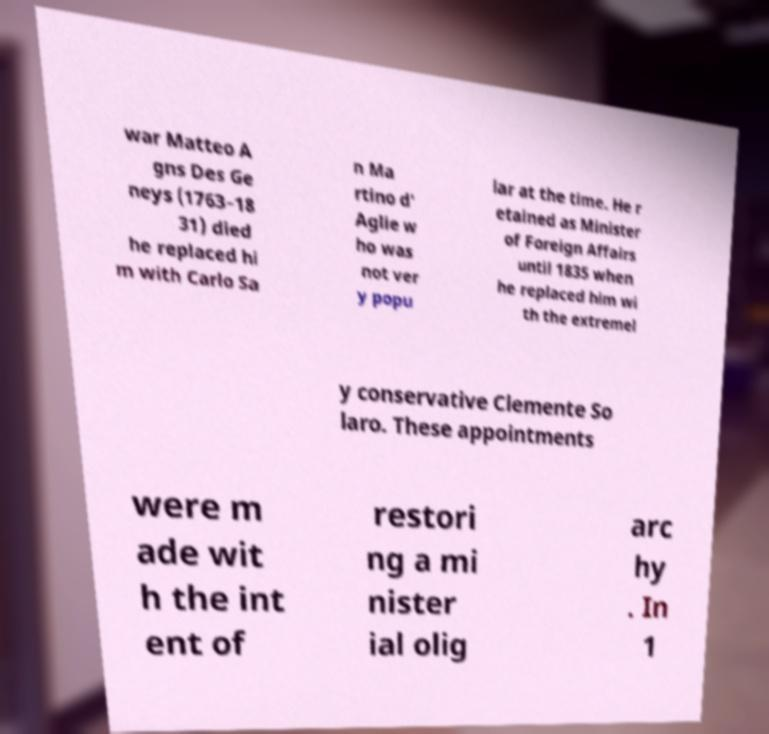Please identify and transcribe the text found in this image. war Matteo A gns Des Ge neys (1763–18 31) died he replaced hi m with Carlo Sa n Ma rtino d' Aglie w ho was not ver y popu lar at the time. He r etained as Minister of Foreign Affairs until 1835 when he replaced him wi th the extremel y conservative Clemente So laro. These appointments were m ade wit h the int ent of restori ng a mi nister ial olig arc hy . In 1 